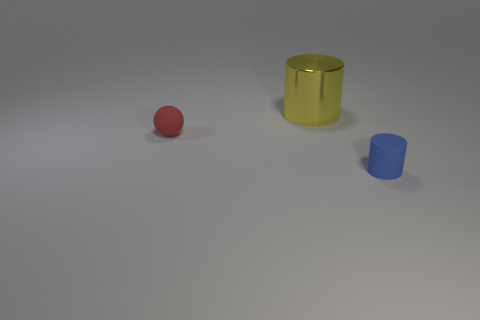Add 1 red matte objects. How many objects exist? 4 Subtract all cylinders. How many objects are left? 1 Add 3 big yellow shiny cylinders. How many big yellow shiny cylinders are left? 4 Add 3 tiny red matte spheres. How many tiny red matte spheres exist? 4 Subtract 0 green blocks. How many objects are left? 3 Subtract all brown objects. Subtract all yellow things. How many objects are left? 2 